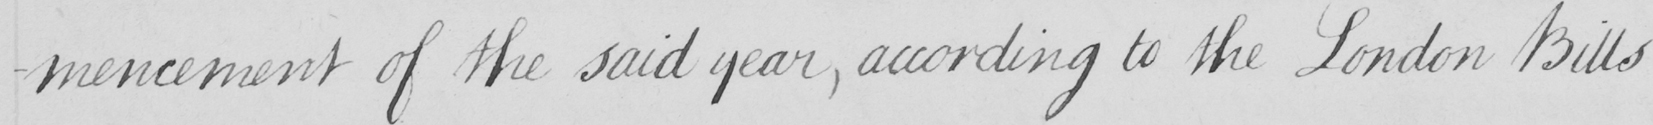Transcribe the text shown in this historical manuscript line. -mencement of the said year , according to the London Bills 